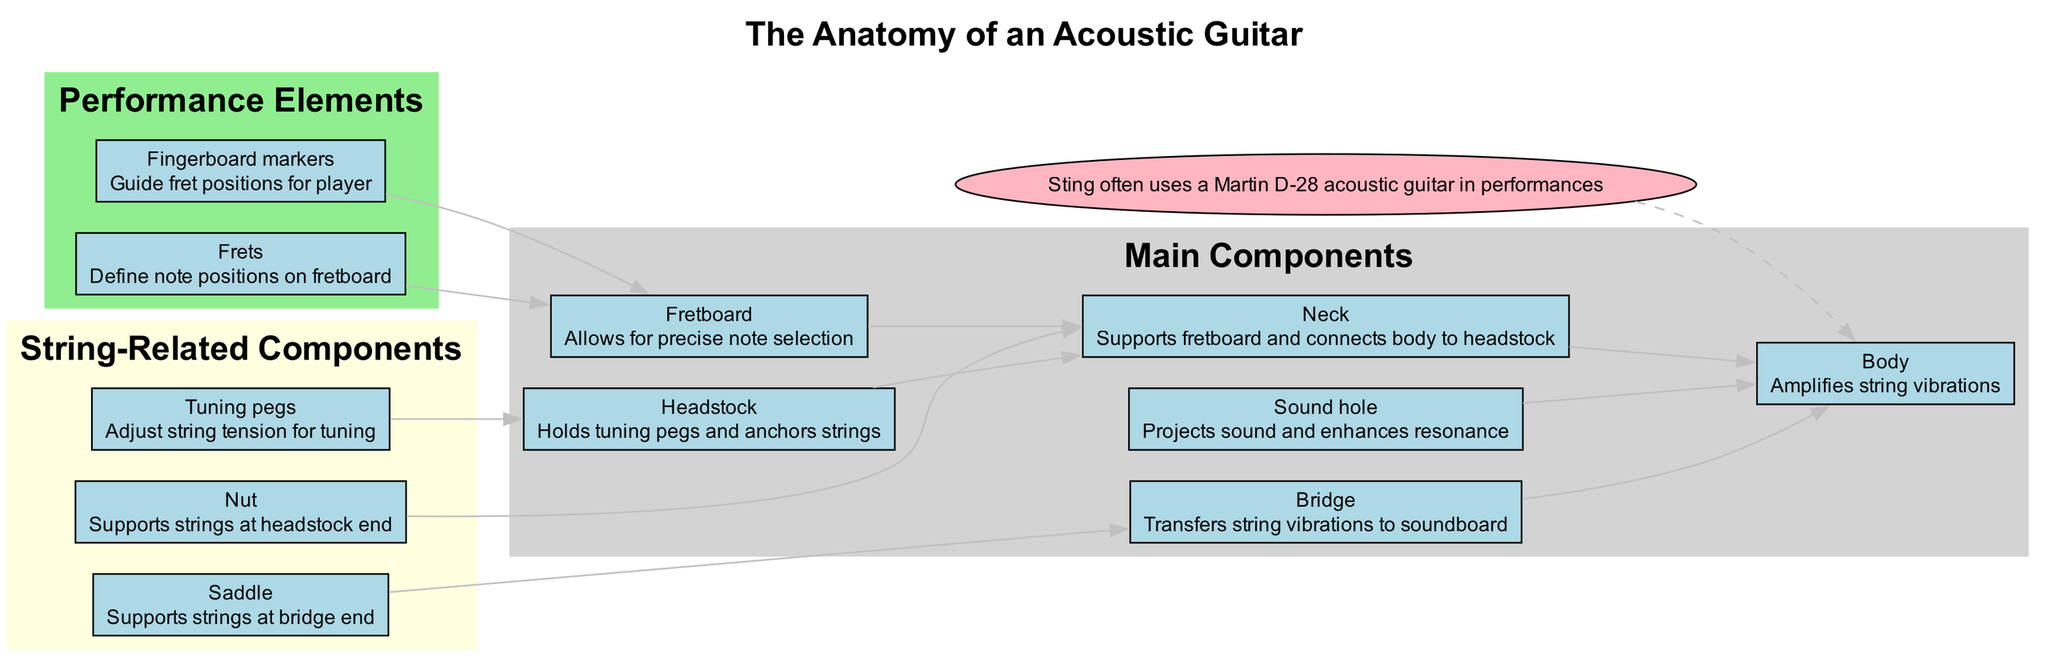What is the function of the Headstock? The diagram labels the Headstock and includes its specific function, which is to hold tuning pegs and anchor strings.
Answer: Holds tuning pegs and anchors strings How many main components are there? The visual information in the main components section shows a total of six components: Headstock, Neck, Fretboard, Body, Sound hole, and Bridge.
Answer: 6 What does the Bridge do? The function of the Bridge, as stated in the diagram, is to transfer string vibrations to the soundboard.
Answer: Transfers string vibrations to soundboard Which component connects the Body and the Headstock? According to the flow of the diagram, the Neck connects the Body and the Headstock, as indicated by the connecting edge.
Answer: Neck What is the role of Frets on the Fretboard? The diagram explains that Frets define note positions on the Fretboard, which is critical for musicians to play precisely.
Answer: Define note positions on fretboard Which components are involved in string support? By examining the labels, the diagram indicates that the Nut and Saddle are responsible for supporting the strings at each end of the guitar (headstock end and bridge end, respectively).
Answer: Nut, Saddle How do the Tuning pegs function in the diagram? The diagram states that Tuning pegs adjust string tension for tuning, illustrating their importance in the overall function of the guitar.
Answer: Adjust string tension for tuning Which part is responsible for sound projection? The Sound hole in the diagram is marked as the part that projects sound and enhances resonance, highlighting its importance in the acoustic design.
Answer: Projects sound and enhances resonance What connects Sting to the Body of the guitar? The diagram provides a special connection noting that Sting uses a Martin D-28 acoustic guitar and shows a dashed edge connecting Sting to the Body as an indication of this relationship.
Answer: Martin D-28 acoustic guitar 